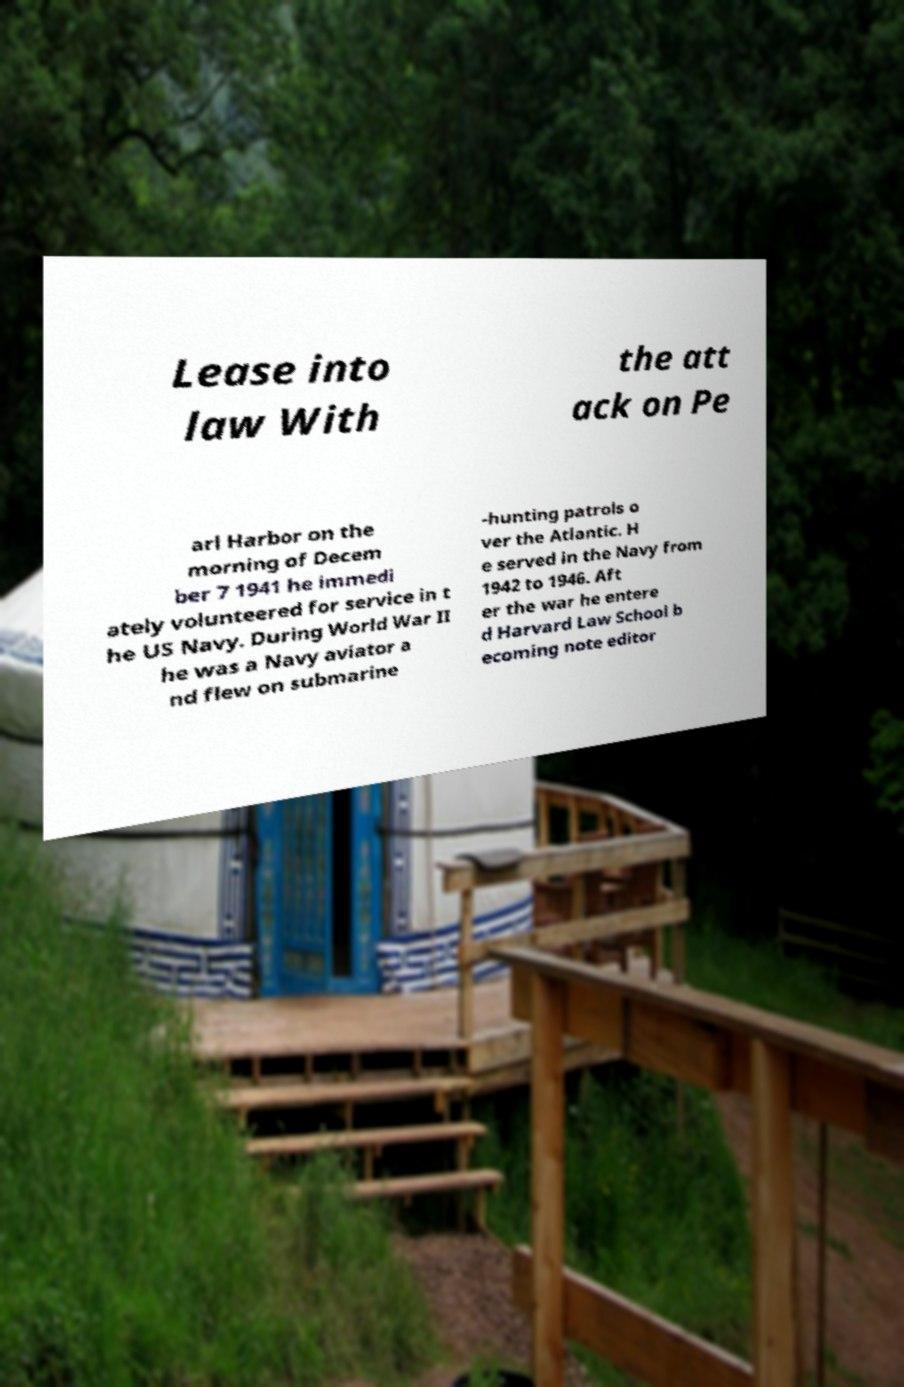Can you read and provide the text displayed in the image?This photo seems to have some interesting text. Can you extract and type it out for me? Lease into law With the att ack on Pe arl Harbor on the morning of Decem ber 7 1941 he immedi ately volunteered for service in t he US Navy. During World War II he was a Navy aviator a nd flew on submarine -hunting patrols o ver the Atlantic. H e served in the Navy from 1942 to 1946. Aft er the war he entere d Harvard Law School b ecoming note editor 